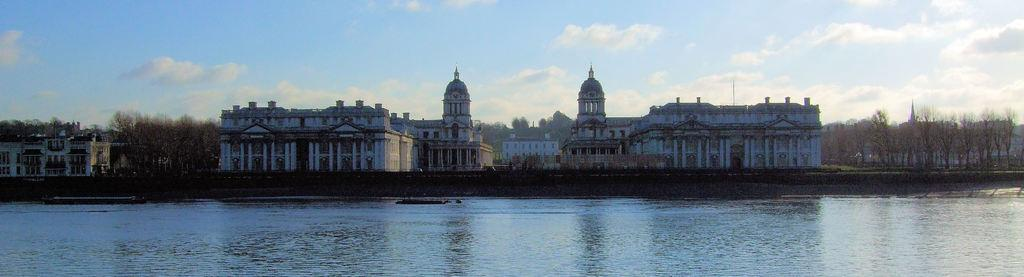What type of structures can be seen in the image? There are buildings with windows in the image. What other natural elements are present in the image? There are trees in the image. What can be seen in the water in the image? The image does not provide information about what can be seen in the water. What is visible in the background of the image? The sky is visible in the background of the image. How many engines are visible in the image? There are no engines present in the image. What type of pie is being served in the image? There is no pie present in the image. 